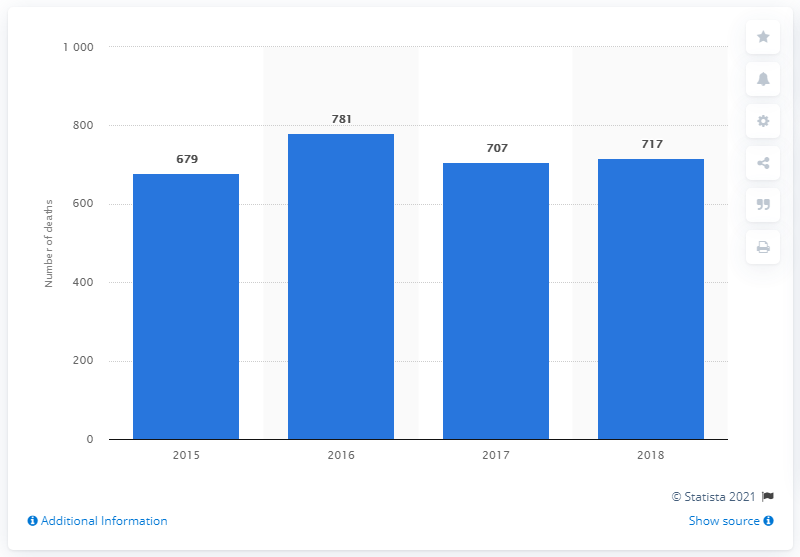Give some essential details in this illustration. There were 781 deaths in Aruba in 2016. In 2018, the total number of deaths in Aruba was 717. 